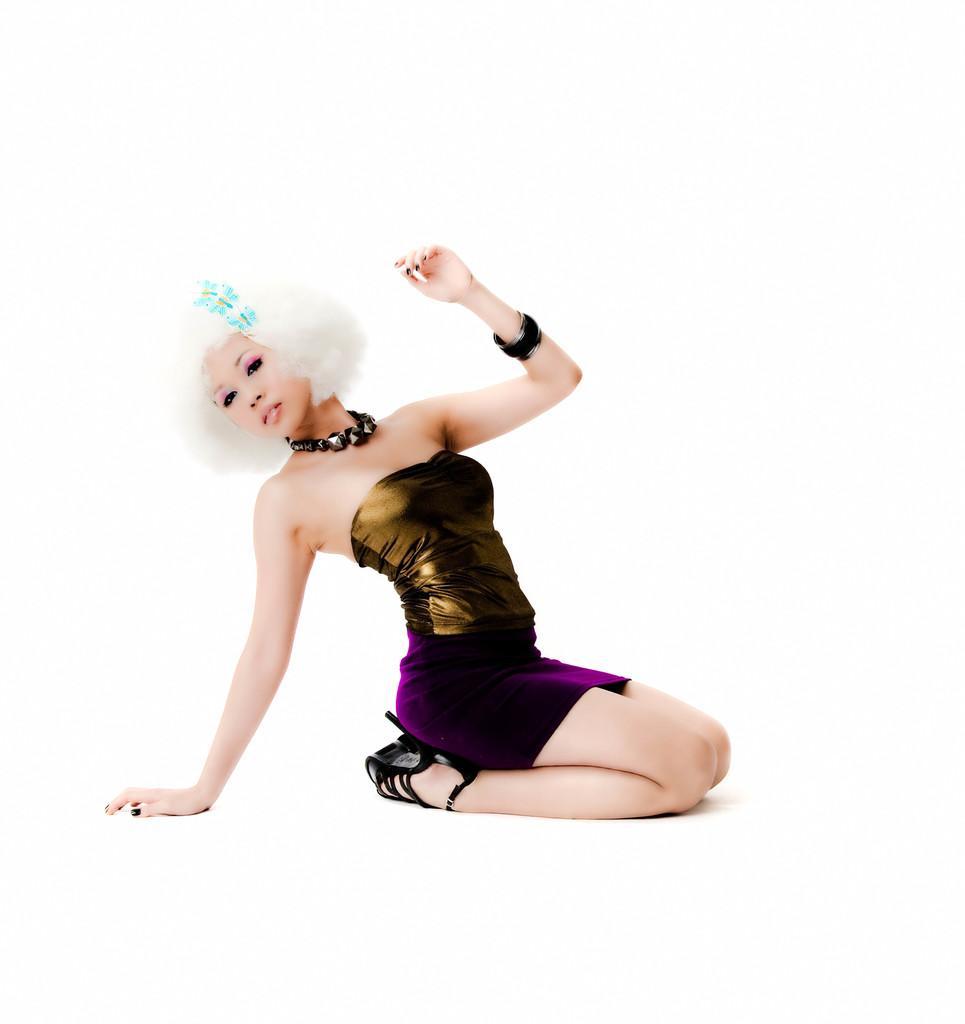Could you give a brief overview of what you see in this image? Background portion of the picture is in white color. In this picture we can see a woman wearing a bracelet, necklace and she is giving a pose. She is beautiful. 